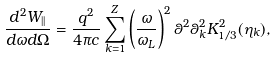<formula> <loc_0><loc_0><loc_500><loc_500>\frac { d ^ { 2 } W _ { | | } } { d \omega d \Omega } = \frac { q ^ { 2 } } { 4 \pi c } \sum _ { k = 1 } ^ { Z } \left ( \frac { \omega } { \omega _ { L } } \right ) ^ { 2 } \theta ^ { 2 } \theta _ { k } ^ { 2 } K _ { 1 / 3 } ^ { 2 } ( \eta _ { k } ) ,</formula> 